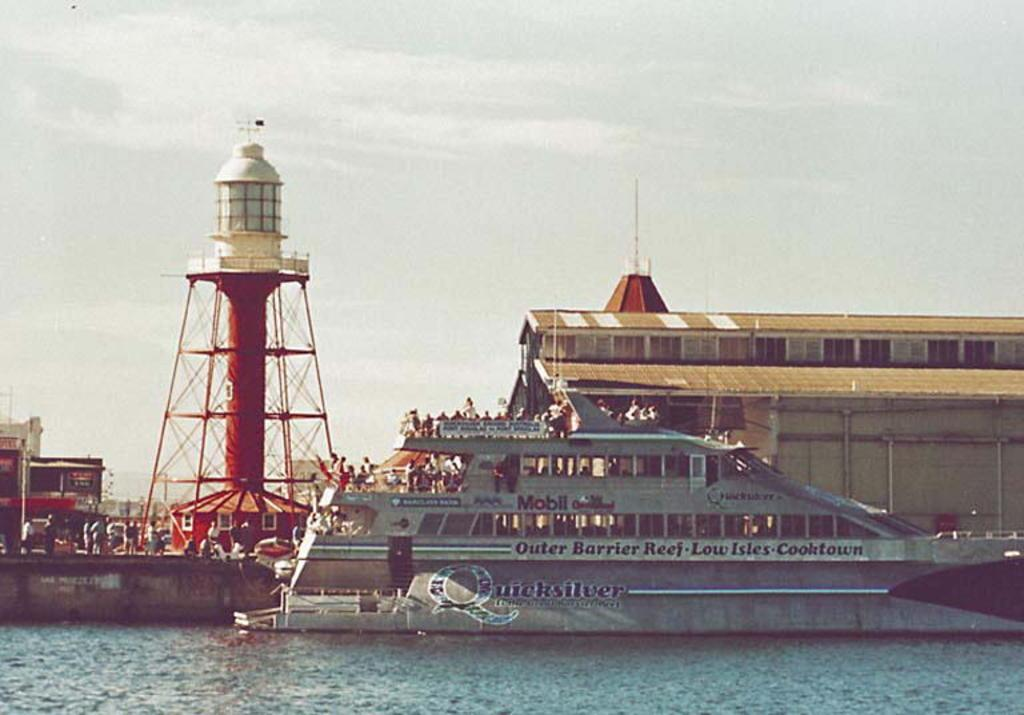Provide a one-sentence caption for the provided image. A tour boat will take passengers to the Outer Barrier Reef. 